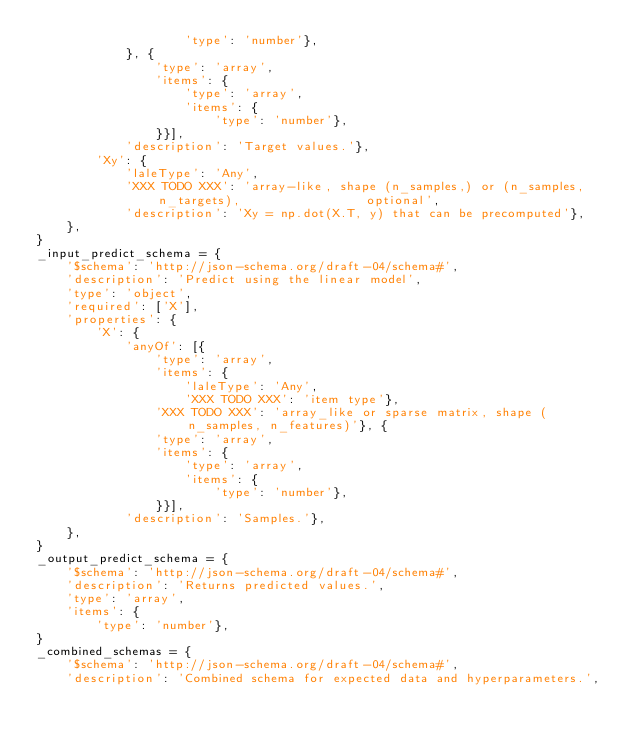<code> <loc_0><loc_0><loc_500><loc_500><_Python_>                    'type': 'number'},
            }, {
                'type': 'array',
                'items': {
                    'type': 'array',
                    'items': {
                        'type': 'number'},
                }}],
            'description': 'Target values.'},
        'Xy': {
            'laleType': 'Any',
            'XXX TODO XXX': 'array-like, shape (n_samples,) or (n_samples, n_targets),                 optional',
            'description': 'Xy = np.dot(X.T, y) that can be precomputed'},
    },
}
_input_predict_schema = {
    '$schema': 'http://json-schema.org/draft-04/schema#',
    'description': 'Predict using the linear model',
    'type': 'object',
    'required': ['X'],
    'properties': {
        'X': {
            'anyOf': [{
                'type': 'array',
                'items': {
                    'laleType': 'Any',
                    'XXX TODO XXX': 'item type'},
                'XXX TODO XXX': 'array_like or sparse matrix, shape (n_samples, n_features)'}, {
                'type': 'array',
                'items': {
                    'type': 'array',
                    'items': {
                        'type': 'number'},
                }}],
            'description': 'Samples.'},
    },
}
_output_predict_schema = {
    '$schema': 'http://json-schema.org/draft-04/schema#',
    'description': 'Returns predicted values.',
    'type': 'array',
    'items': {
        'type': 'number'},
}
_combined_schemas = {
    '$schema': 'http://json-schema.org/draft-04/schema#',
    'description': 'Combined schema for expected data and hyperparameters.',</code> 